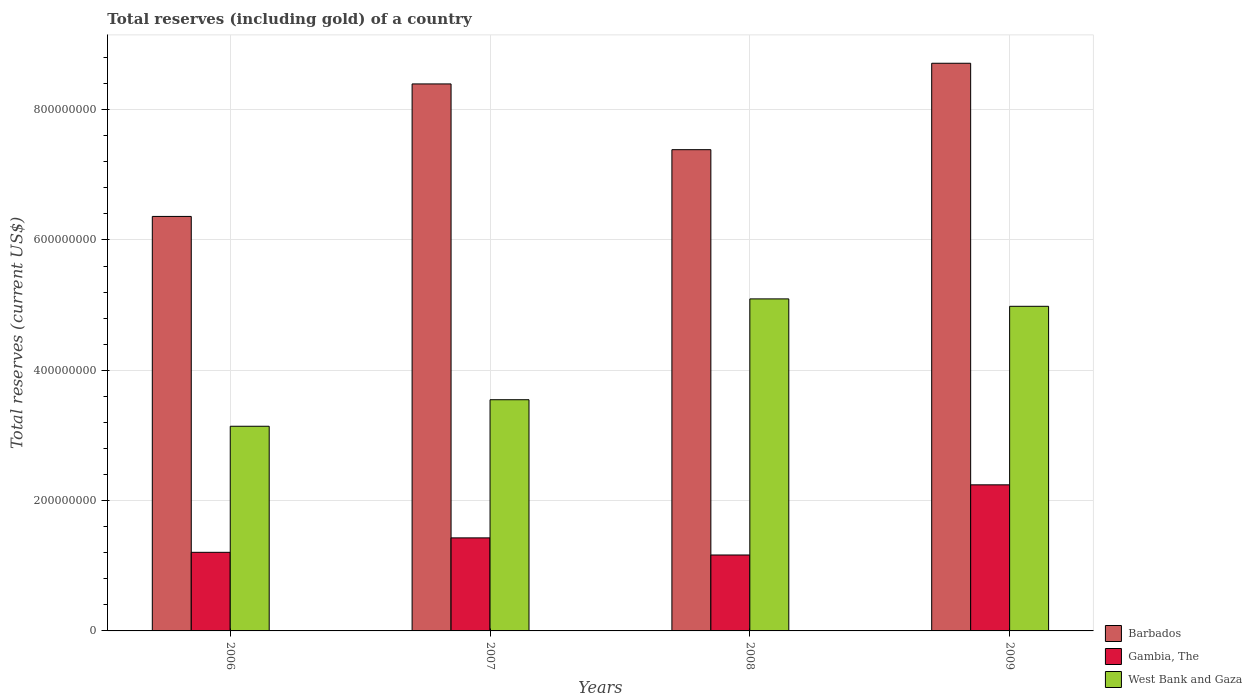How many different coloured bars are there?
Give a very brief answer. 3. Are the number of bars per tick equal to the number of legend labels?
Keep it short and to the point. Yes. Are the number of bars on each tick of the X-axis equal?
Ensure brevity in your answer.  Yes. How many bars are there on the 3rd tick from the right?
Your answer should be very brief. 3. In how many cases, is the number of bars for a given year not equal to the number of legend labels?
Your answer should be very brief. 0. What is the total reserves (including gold) in Barbados in 2009?
Keep it short and to the point. 8.71e+08. Across all years, what is the maximum total reserves (including gold) in Gambia, The?
Offer a very short reply. 2.24e+08. Across all years, what is the minimum total reserves (including gold) in Gambia, The?
Your response must be concise. 1.17e+08. In which year was the total reserves (including gold) in Gambia, The minimum?
Give a very brief answer. 2008. What is the total total reserves (including gold) in West Bank and Gaza in the graph?
Offer a terse response. 1.68e+09. What is the difference between the total reserves (including gold) in West Bank and Gaza in 2006 and that in 2007?
Provide a short and direct response. -4.07e+07. What is the difference between the total reserves (including gold) in Barbados in 2008 and the total reserves (including gold) in West Bank and Gaza in 2006?
Provide a short and direct response. 4.24e+08. What is the average total reserves (including gold) in West Bank and Gaza per year?
Keep it short and to the point. 4.19e+08. In the year 2008, what is the difference between the total reserves (including gold) in West Bank and Gaza and total reserves (including gold) in Gambia, The?
Ensure brevity in your answer.  3.93e+08. What is the ratio of the total reserves (including gold) in West Bank and Gaza in 2007 to that in 2008?
Your answer should be very brief. 0.7. Is the total reserves (including gold) in Gambia, The in 2007 less than that in 2008?
Your answer should be compact. No. What is the difference between the highest and the second highest total reserves (including gold) in Barbados?
Provide a short and direct response. 3.17e+07. What is the difference between the highest and the lowest total reserves (including gold) in West Bank and Gaza?
Make the answer very short. 1.95e+08. In how many years, is the total reserves (including gold) in Gambia, The greater than the average total reserves (including gold) in Gambia, The taken over all years?
Your response must be concise. 1. Is the sum of the total reserves (including gold) in Barbados in 2007 and 2008 greater than the maximum total reserves (including gold) in West Bank and Gaza across all years?
Your answer should be very brief. Yes. What does the 1st bar from the left in 2006 represents?
Give a very brief answer. Barbados. What does the 1st bar from the right in 2006 represents?
Ensure brevity in your answer.  West Bank and Gaza. How many bars are there?
Offer a very short reply. 12. Are all the bars in the graph horizontal?
Your answer should be compact. No. What is the difference between two consecutive major ticks on the Y-axis?
Your answer should be very brief. 2.00e+08. Are the values on the major ticks of Y-axis written in scientific E-notation?
Offer a very short reply. No. Does the graph contain any zero values?
Your response must be concise. No. Does the graph contain grids?
Your response must be concise. Yes. How many legend labels are there?
Provide a succinct answer. 3. How are the legend labels stacked?
Your response must be concise. Vertical. What is the title of the graph?
Offer a very short reply. Total reserves (including gold) of a country. What is the label or title of the X-axis?
Your response must be concise. Years. What is the label or title of the Y-axis?
Provide a short and direct response. Total reserves (current US$). What is the Total reserves (current US$) in Barbados in 2006?
Give a very brief answer. 6.36e+08. What is the Total reserves (current US$) in Gambia, The in 2006?
Your answer should be compact. 1.21e+08. What is the Total reserves (current US$) in West Bank and Gaza in 2006?
Your answer should be very brief. 3.14e+08. What is the Total reserves (current US$) in Barbados in 2007?
Your answer should be compact. 8.39e+08. What is the Total reserves (current US$) in Gambia, The in 2007?
Your answer should be compact. 1.43e+08. What is the Total reserves (current US$) of West Bank and Gaza in 2007?
Ensure brevity in your answer.  3.55e+08. What is the Total reserves (current US$) in Barbados in 2008?
Offer a terse response. 7.39e+08. What is the Total reserves (current US$) of Gambia, The in 2008?
Ensure brevity in your answer.  1.17e+08. What is the Total reserves (current US$) in West Bank and Gaza in 2008?
Give a very brief answer. 5.10e+08. What is the Total reserves (current US$) of Barbados in 2009?
Offer a terse response. 8.71e+08. What is the Total reserves (current US$) in Gambia, The in 2009?
Provide a succinct answer. 2.24e+08. What is the Total reserves (current US$) in West Bank and Gaza in 2009?
Ensure brevity in your answer.  4.98e+08. Across all years, what is the maximum Total reserves (current US$) of Barbados?
Provide a short and direct response. 8.71e+08. Across all years, what is the maximum Total reserves (current US$) in Gambia, The?
Offer a very short reply. 2.24e+08. Across all years, what is the maximum Total reserves (current US$) of West Bank and Gaza?
Make the answer very short. 5.10e+08. Across all years, what is the minimum Total reserves (current US$) of Barbados?
Make the answer very short. 6.36e+08. Across all years, what is the minimum Total reserves (current US$) in Gambia, The?
Your answer should be compact. 1.17e+08. Across all years, what is the minimum Total reserves (current US$) in West Bank and Gaza?
Keep it short and to the point. 3.14e+08. What is the total Total reserves (current US$) in Barbados in the graph?
Ensure brevity in your answer.  3.09e+09. What is the total Total reserves (current US$) of Gambia, The in the graph?
Your answer should be very brief. 6.04e+08. What is the total Total reserves (current US$) in West Bank and Gaza in the graph?
Give a very brief answer. 1.68e+09. What is the difference between the Total reserves (current US$) of Barbados in 2006 and that in 2007?
Your answer should be very brief. -2.03e+08. What is the difference between the Total reserves (current US$) of Gambia, The in 2006 and that in 2007?
Provide a short and direct response. -2.22e+07. What is the difference between the Total reserves (current US$) of West Bank and Gaza in 2006 and that in 2007?
Your answer should be compact. -4.07e+07. What is the difference between the Total reserves (current US$) in Barbados in 2006 and that in 2008?
Ensure brevity in your answer.  -1.02e+08. What is the difference between the Total reserves (current US$) in Gambia, The in 2006 and that in 2008?
Offer a very short reply. 4.10e+06. What is the difference between the Total reserves (current US$) of West Bank and Gaza in 2006 and that in 2008?
Offer a very short reply. -1.95e+08. What is the difference between the Total reserves (current US$) of Barbados in 2006 and that in 2009?
Provide a succinct answer. -2.35e+08. What is the difference between the Total reserves (current US$) of Gambia, The in 2006 and that in 2009?
Your answer should be compact. -1.04e+08. What is the difference between the Total reserves (current US$) of West Bank and Gaza in 2006 and that in 2009?
Your answer should be compact. -1.84e+08. What is the difference between the Total reserves (current US$) in Barbados in 2007 and that in 2008?
Make the answer very short. 1.01e+08. What is the difference between the Total reserves (current US$) of Gambia, The in 2007 and that in 2008?
Offer a very short reply. 2.63e+07. What is the difference between the Total reserves (current US$) in West Bank and Gaza in 2007 and that in 2008?
Provide a succinct answer. -1.55e+08. What is the difference between the Total reserves (current US$) of Barbados in 2007 and that in 2009?
Make the answer very short. -3.17e+07. What is the difference between the Total reserves (current US$) in Gambia, The in 2007 and that in 2009?
Provide a succinct answer. -8.14e+07. What is the difference between the Total reserves (current US$) in West Bank and Gaza in 2007 and that in 2009?
Make the answer very short. -1.43e+08. What is the difference between the Total reserves (current US$) in Barbados in 2008 and that in 2009?
Your answer should be very brief. -1.33e+08. What is the difference between the Total reserves (current US$) of Gambia, The in 2008 and that in 2009?
Provide a succinct answer. -1.08e+08. What is the difference between the Total reserves (current US$) in West Bank and Gaza in 2008 and that in 2009?
Offer a terse response. 1.14e+07. What is the difference between the Total reserves (current US$) of Barbados in 2006 and the Total reserves (current US$) of Gambia, The in 2007?
Provide a succinct answer. 4.93e+08. What is the difference between the Total reserves (current US$) in Barbados in 2006 and the Total reserves (current US$) in West Bank and Gaza in 2007?
Provide a succinct answer. 2.81e+08. What is the difference between the Total reserves (current US$) of Gambia, The in 2006 and the Total reserves (current US$) of West Bank and Gaza in 2007?
Provide a short and direct response. -2.34e+08. What is the difference between the Total reserves (current US$) in Barbados in 2006 and the Total reserves (current US$) in Gambia, The in 2008?
Ensure brevity in your answer.  5.20e+08. What is the difference between the Total reserves (current US$) in Barbados in 2006 and the Total reserves (current US$) in West Bank and Gaza in 2008?
Give a very brief answer. 1.27e+08. What is the difference between the Total reserves (current US$) of Gambia, The in 2006 and the Total reserves (current US$) of West Bank and Gaza in 2008?
Make the answer very short. -3.89e+08. What is the difference between the Total reserves (current US$) of Barbados in 2006 and the Total reserves (current US$) of Gambia, The in 2009?
Give a very brief answer. 4.12e+08. What is the difference between the Total reserves (current US$) of Barbados in 2006 and the Total reserves (current US$) of West Bank and Gaza in 2009?
Keep it short and to the point. 1.38e+08. What is the difference between the Total reserves (current US$) in Gambia, The in 2006 and the Total reserves (current US$) in West Bank and Gaza in 2009?
Keep it short and to the point. -3.78e+08. What is the difference between the Total reserves (current US$) of Barbados in 2007 and the Total reserves (current US$) of Gambia, The in 2008?
Provide a succinct answer. 7.23e+08. What is the difference between the Total reserves (current US$) in Barbados in 2007 and the Total reserves (current US$) in West Bank and Gaza in 2008?
Keep it short and to the point. 3.30e+08. What is the difference between the Total reserves (current US$) in Gambia, The in 2007 and the Total reserves (current US$) in West Bank and Gaza in 2008?
Provide a short and direct response. -3.67e+08. What is the difference between the Total reserves (current US$) of Barbados in 2007 and the Total reserves (current US$) of Gambia, The in 2009?
Ensure brevity in your answer.  6.15e+08. What is the difference between the Total reserves (current US$) in Barbados in 2007 and the Total reserves (current US$) in West Bank and Gaza in 2009?
Ensure brevity in your answer.  3.41e+08. What is the difference between the Total reserves (current US$) in Gambia, The in 2007 and the Total reserves (current US$) in West Bank and Gaza in 2009?
Your answer should be very brief. -3.55e+08. What is the difference between the Total reserves (current US$) of Barbados in 2008 and the Total reserves (current US$) of Gambia, The in 2009?
Keep it short and to the point. 5.14e+08. What is the difference between the Total reserves (current US$) in Barbados in 2008 and the Total reserves (current US$) in West Bank and Gaza in 2009?
Keep it short and to the point. 2.40e+08. What is the difference between the Total reserves (current US$) in Gambia, The in 2008 and the Total reserves (current US$) in West Bank and Gaza in 2009?
Ensure brevity in your answer.  -3.82e+08. What is the average Total reserves (current US$) in Barbados per year?
Offer a terse response. 7.71e+08. What is the average Total reserves (current US$) of Gambia, The per year?
Provide a succinct answer. 1.51e+08. What is the average Total reserves (current US$) of West Bank and Gaza per year?
Give a very brief answer. 4.19e+08. In the year 2006, what is the difference between the Total reserves (current US$) in Barbados and Total reserves (current US$) in Gambia, The?
Your response must be concise. 5.15e+08. In the year 2006, what is the difference between the Total reserves (current US$) in Barbados and Total reserves (current US$) in West Bank and Gaza?
Your response must be concise. 3.22e+08. In the year 2006, what is the difference between the Total reserves (current US$) of Gambia, The and Total reserves (current US$) of West Bank and Gaza?
Offer a terse response. -1.93e+08. In the year 2007, what is the difference between the Total reserves (current US$) in Barbados and Total reserves (current US$) in Gambia, The?
Keep it short and to the point. 6.97e+08. In the year 2007, what is the difference between the Total reserves (current US$) of Barbados and Total reserves (current US$) of West Bank and Gaza?
Offer a terse response. 4.85e+08. In the year 2007, what is the difference between the Total reserves (current US$) in Gambia, The and Total reserves (current US$) in West Bank and Gaza?
Keep it short and to the point. -2.12e+08. In the year 2008, what is the difference between the Total reserves (current US$) of Barbados and Total reserves (current US$) of Gambia, The?
Offer a terse response. 6.22e+08. In the year 2008, what is the difference between the Total reserves (current US$) of Barbados and Total reserves (current US$) of West Bank and Gaza?
Offer a terse response. 2.29e+08. In the year 2008, what is the difference between the Total reserves (current US$) in Gambia, The and Total reserves (current US$) in West Bank and Gaza?
Keep it short and to the point. -3.93e+08. In the year 2009, what is the difference between the Total reserves (current US$) of Barbados and Total reserves (current US$) of Gambia, The?
Your answer should be compact. 6.47e+08. In the year 2009, what is the difference between the Total reserves (current US$) in Barbados and Total reserves (current US$) in West Bank and Gaza?
Provide a succinct answer. 3.73e+08. In the year 2009, what is the difference between the Total reserves (current US$) of Gambia, The and Total reserves (current US$) of West Bank and Gaza?
Your answer should be very brief. -2.74e+08. What is the ratio of the Total reserves (current US$) of Barbados in 2006 to that in 2007?
Keep it short and to the point. 0.76. What is the ratio of the Total reserves (current US$) in Gambia, The in 2006 to that in 2007?
Your answer should be very brief. 0.84. What is the ratio of the Total reserves (current US$) of West Bank and Gaza in 2006 to that in 2007?
Ensure brevity in your answer.  0.89. What is the ratio of the Total reserves (current US$) in Barbados in 2006 to that in 2008?
Keep it short and to the point. 0.86. What is the ratio of the Total reserves (current US$) of Gambia, The in 2006 to that in 2008?
Provide a short and direct response. 1.04. What is the ratio of the Total reserves (current US$) of West Bank and Gaza in 2006 to that in 2008?
Provide a short and direct response. 0.62. What is the ratio of the Total reserves (current US$) in Barbados in 2006 to that in 2009?
Provide a succinct answer. 0.73. What is the ratio of the Total reserves (current US$) in Gambia, The in 2006 to that in 2009?
Your response must be concise. 0.54. What is the ratio of the Total reserves (current US$) of West Bank and Gaza in 2006 to that in 2009?
Your response must be concise. 0.63. What is the ratio of the Total reserves (current US$) in Barbados in 2007 to that in 2008?
Give a very brief answer. 1.14. What is the ratio of the Total reserves (current US$) in Gambia, The in 2007 to that in 2008?
Your answer should be very brief. 1.23. What is the ratio of the Total reserves (current US$) of West Bank and Gaza in 2007 to that in 2008?
Keep it short and to the point. 0.7. What is the ratio of the Total reserves (current US$) in Barbados in 2007 to that in 2009?
Provide a short and direct response. 0.96. What is the ratio of the Total reserves (current US$) in Gambia, The in 2007 to that in 2009?
Give a very brief answer. 0.64. What is the ratio of the Total reserves (current US$) in West Bank and Gaza in 2007 to that in 2009?
Provide a short and direct response. 0.71. What is the ratio of the Total reserves (current US$) in Barbados in 2008 to that in 2009?
Provide a succinct answer. 0.85. What is the ratio of the Total reserves (current US$) of Gambia, The in 2008 to that in 2009?
Make the answer very short. 0.52. What is the ratio of the Total reserves (current US$) of West Bank and Gaza in 2008 to that in 2009?
Your response must be concise. 1.02. What is the difference between the highest and the second highest Total reserves (current US$) of Barbados?
Ensure brevity in your answer.  3.17e+07. What is the difference between the highest and the second highest Total reserves (current US$) of Gambia, The?
Provide a short and direct response. 8.14e+07. What is the difference between the highest and the second highest Total reserves (current US$) of West Bank and Gaza?
Make the answer very short. 1.14e+07. What is the difference between the highest and the lowest Total reserves (current US$) in Barbados?
Keep it short and to the point. 2.35e+08. What is the difference between the highest and the lowest Total reserves (current US$) in Gambia, The?
Ensure brevity in your answer.  1.08e+08. What is the difference between the highest and the lowest Total reserves (current US$) of West Bank and Gaza?
Your response must be concise. 1.95e+08. 